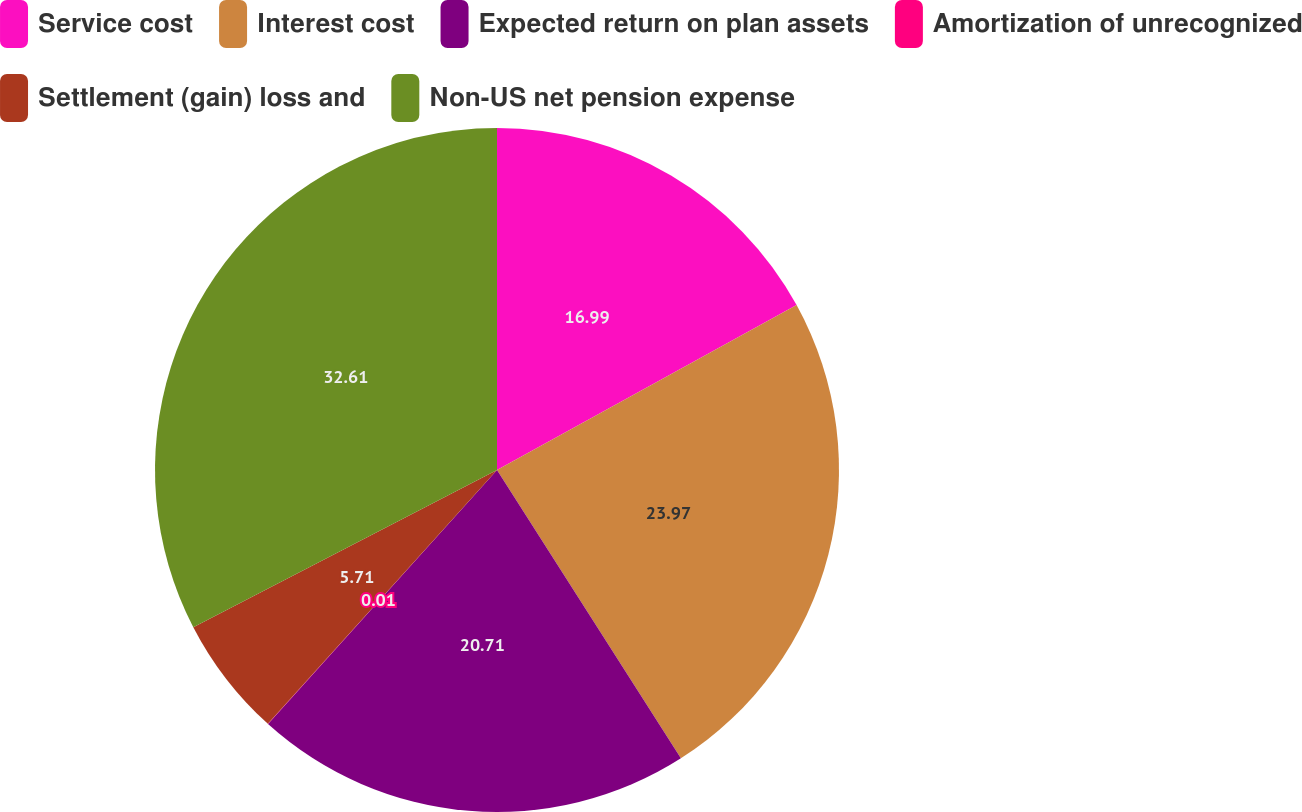Convert chart. <chart><loc_0><loc_0><loc_500><loc_500><pie_chart><fcel>Service cost<fcel>Interest cost<fcel>Expected return on plan assets<fcel>Amortization of unrecognized<fcel>Settlement (gain) loss and<fcel>Non-US net pension expense<nl><fcel>16.99%<fcel>23.97%<fcel>20.71%<fcel>0.01%<fcel>5.71%<fcel>32.6%<nl></chart> 